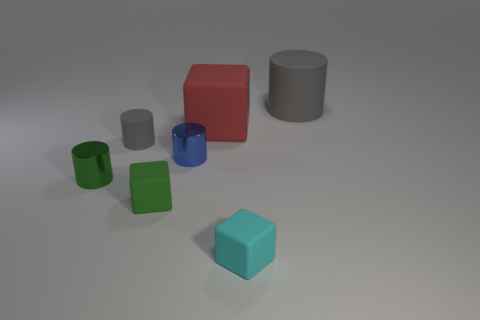Does the big rubber cylinder have the same color as the tiny rubber cylinder?
Offer a very short reply. Yes. Do the blue metal thing and the red cube have the same size?
Give a very brief answer. No. What material is the big gray cylinder?
Provide a short and direct response. Rubber. There is a large cylinder that is made of the same material as the tiny cyan cube; what is its color?
Your answer should be very brief. Gray. Is the number of large matte cubes on the left side of the green matte block less than the number of tiny green cubes that are in front of the blue thing?
Ensure brevity in your answer.  Yes. How many things are blue cylinders or matte objects on the right side of the red object?
Offer a terse response. 3. There is a green cylinder that is the same size as the blue shiny cylinder; what material is it?
Offer a terse response. Metal. Do the large cylinder and the small blue object have the same material?
Offer a very short reply. No. There is a object that is in front of the small blue shiny thing and behind the small green matte block; what is its color?
Offer a terse response. Green. Do the matte object that is left of the tiny green rubber cube and the big rubber cylinder have the same color?
Provide a succinct answer. Yes. 